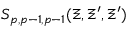Convert formula to latex. <formula><loc_0><loc_0><loc_500><loc_500>S _ { p , p - 1 , p - 1 } ( \Xi , \Xi ^ { \prime } , \Xi ^ { \prime } )</formula> 